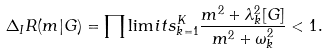<formula> <loc_0><loc_0><loc_500><loc_500>\Delta _ { I } R ( m | G ) = \prod \lim i t s _ { k = 1 } ^ { K } \frac { m ^ { 2 } + \lambda _ { k } ^ { 2 } [ G ] } { m ^ { 2 } + \omega _ { k } ^ { 2 } } < 1 .</formula> 